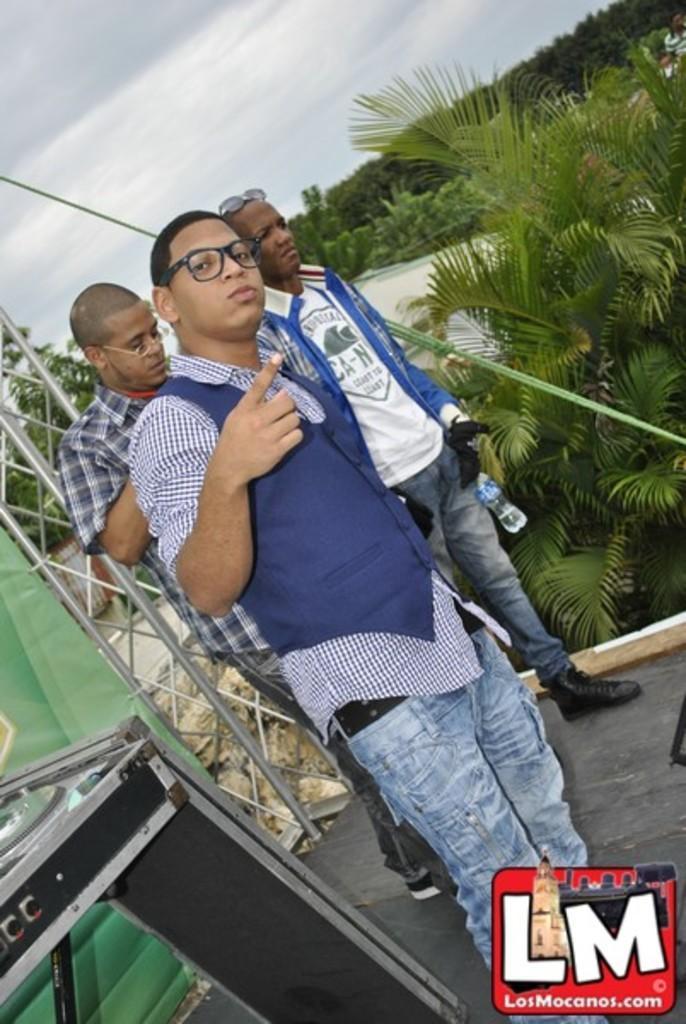Please provide a concise description of this image. In the center of the image there are people standing. At the bottom of the image there is logo. In the background of the image there are trees. At the top of the image there is sky. 